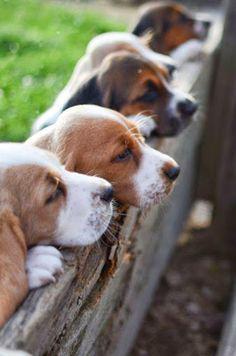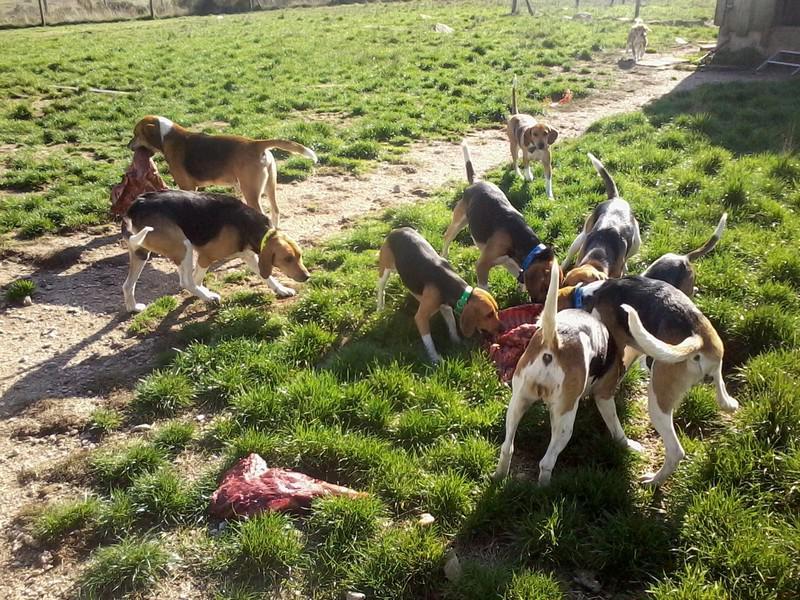The first image is the image on the left, the second image is the image on the right. Examine the images to the left and right. Is the description "A bloody carcass lies in the grass in one image." accurate? Answer yes or no. Yes. 